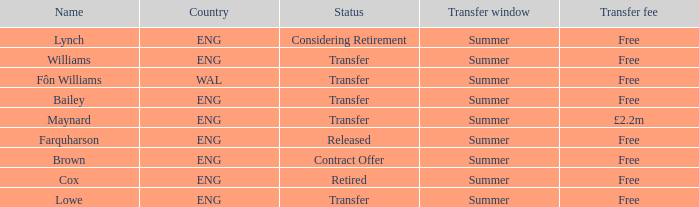What is the title of the complimentary transfer charge with a transfer condition and an eng nation? Bailey, Williams, Lowe. 